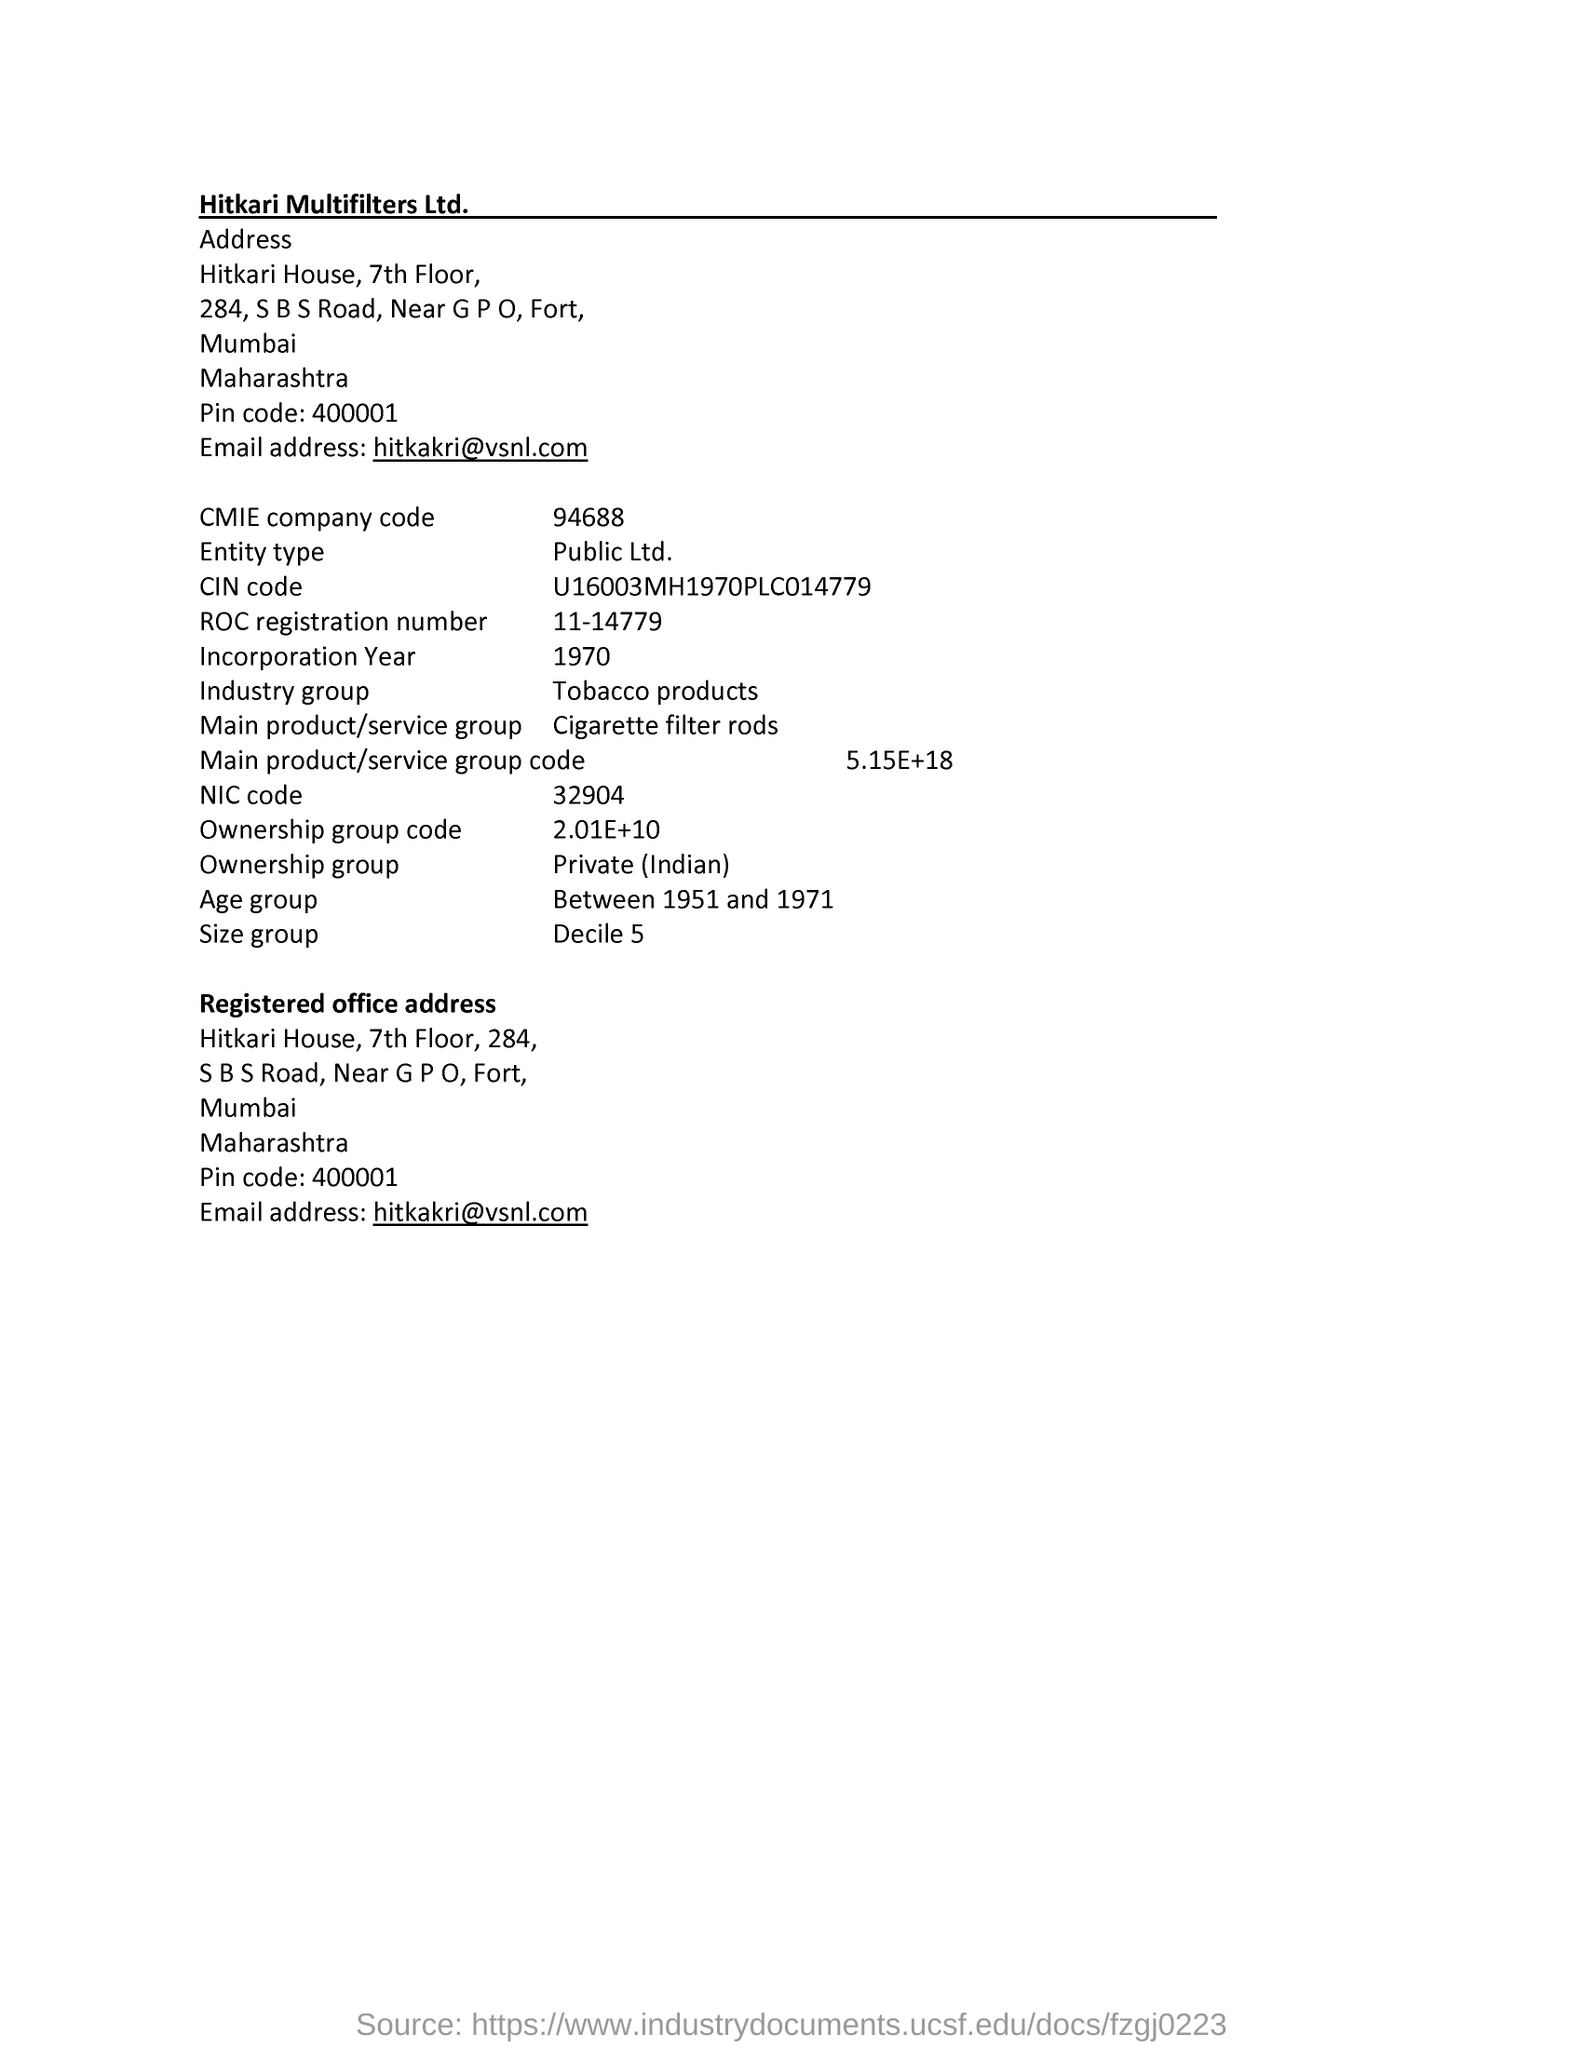Indicate a few pertinent items in this graphic. The term "industry group" refers to a collection of businesses or organizations that operate within a specific industry, such as the tobacco products industry. The ROC registration number 11-14779 refers to a specific document or entity registered with the Registrar of Companies. The CMIE company code is 94688. The organization mentioned in the document is Hitkari Multifilters Ltd. 